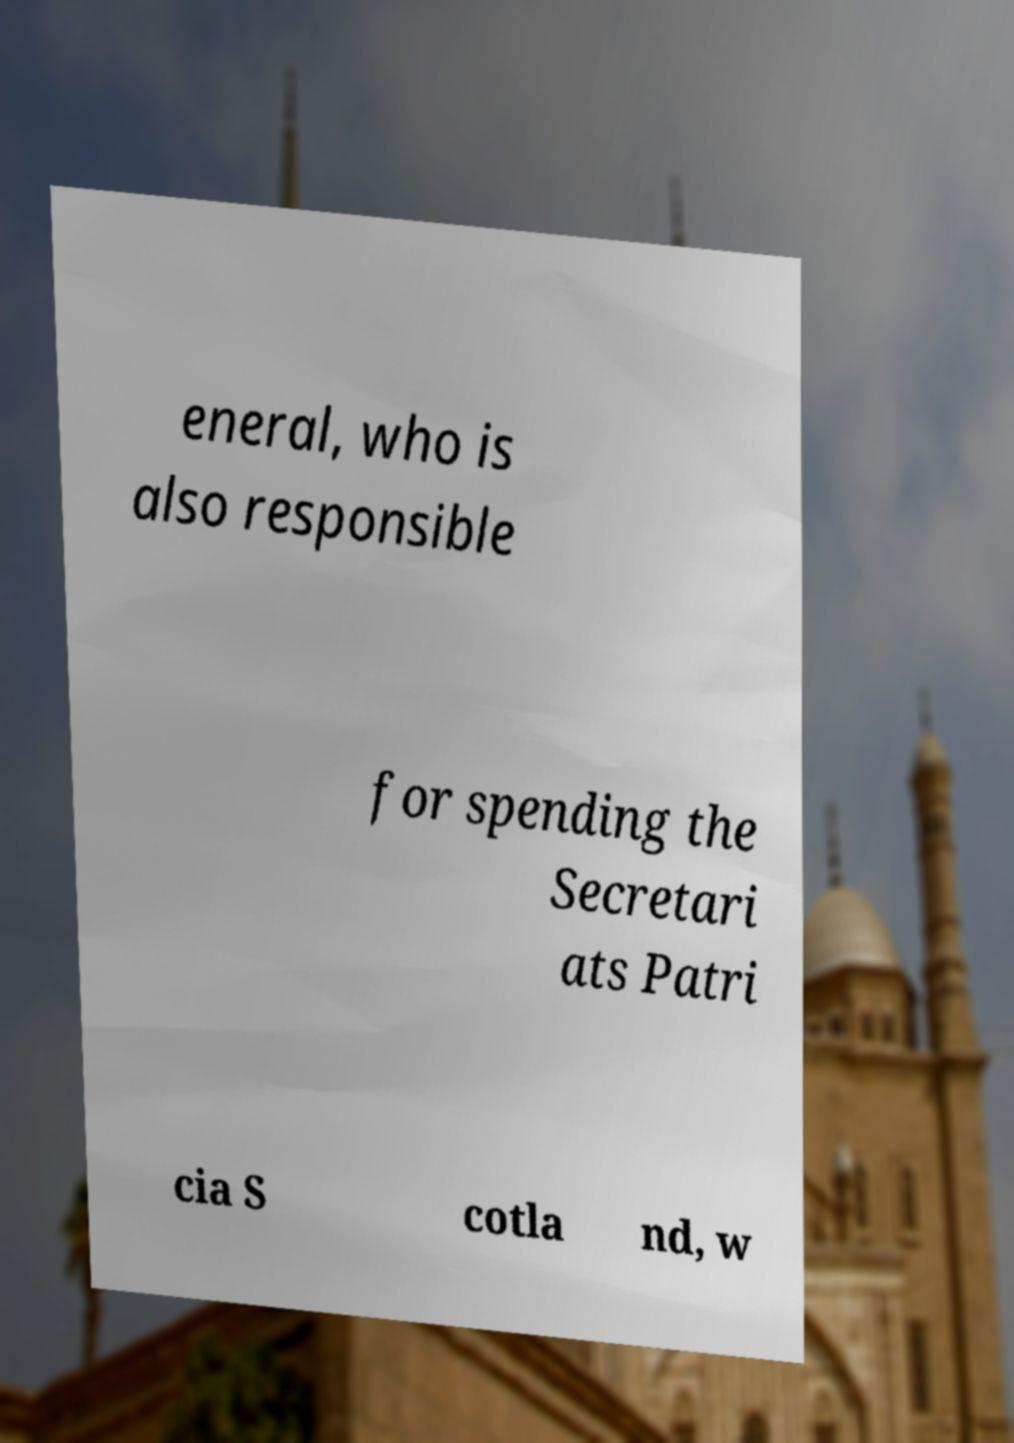What messages or text are displayed in this image? I need them in a readable, typed format. eneral, who is also responsible for spending the Secretari ats Patri cia S cotla nd, w 